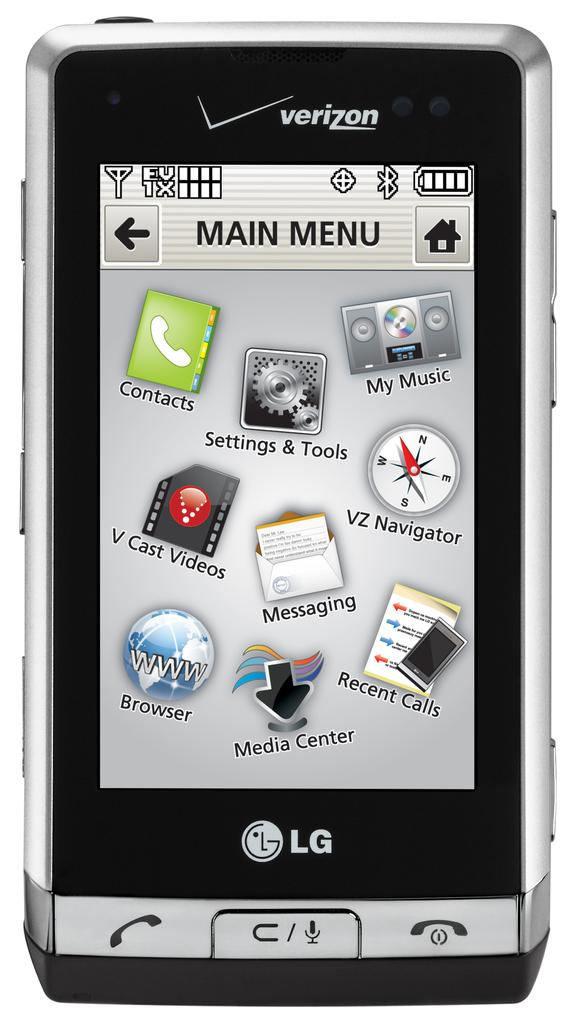<image>
Provide a brief description of the given image. A Verizon cell phone with the main menu screen on. 